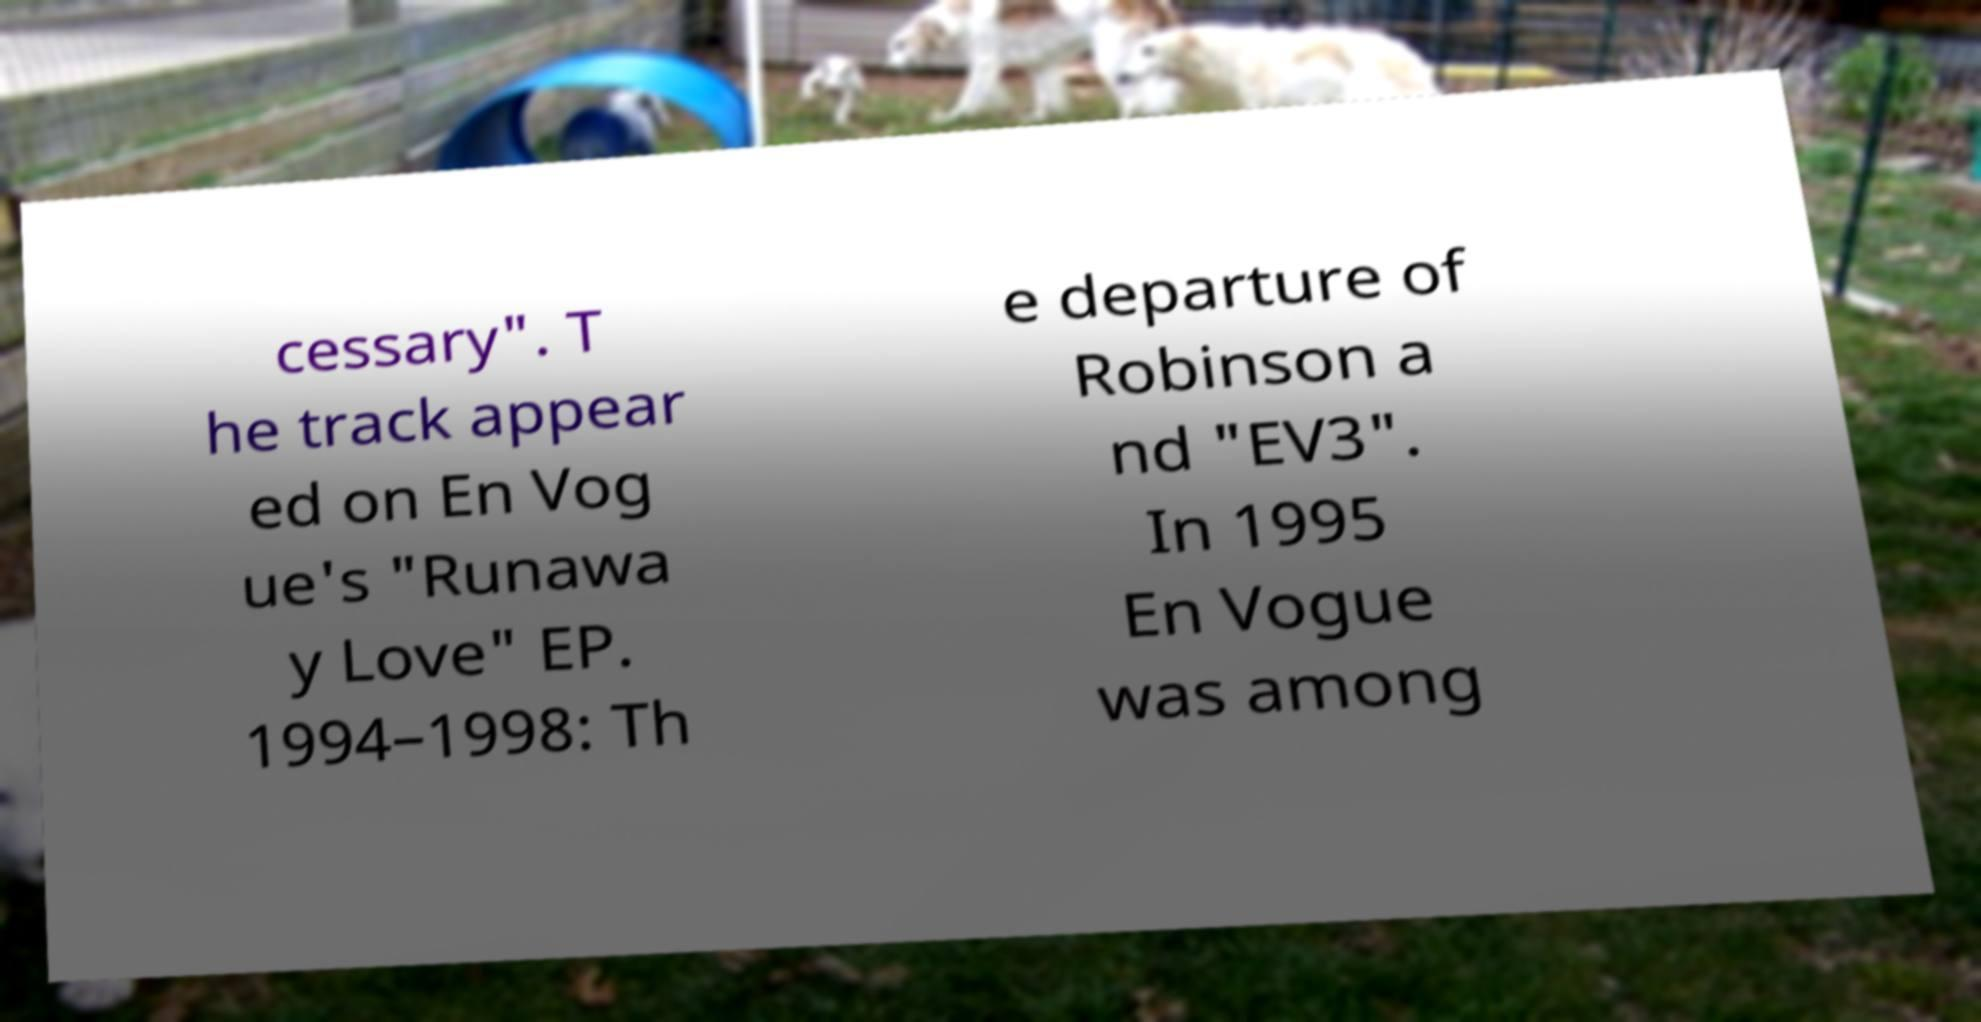Can you accurately transcribe the text from the provided image for me? cessary". T he track appear ed on En Vog ue's "Runawa y Love" EP. 1994–1998: Th e departure of Robinson a nd "EV3". In 1995 En Vogue was among 